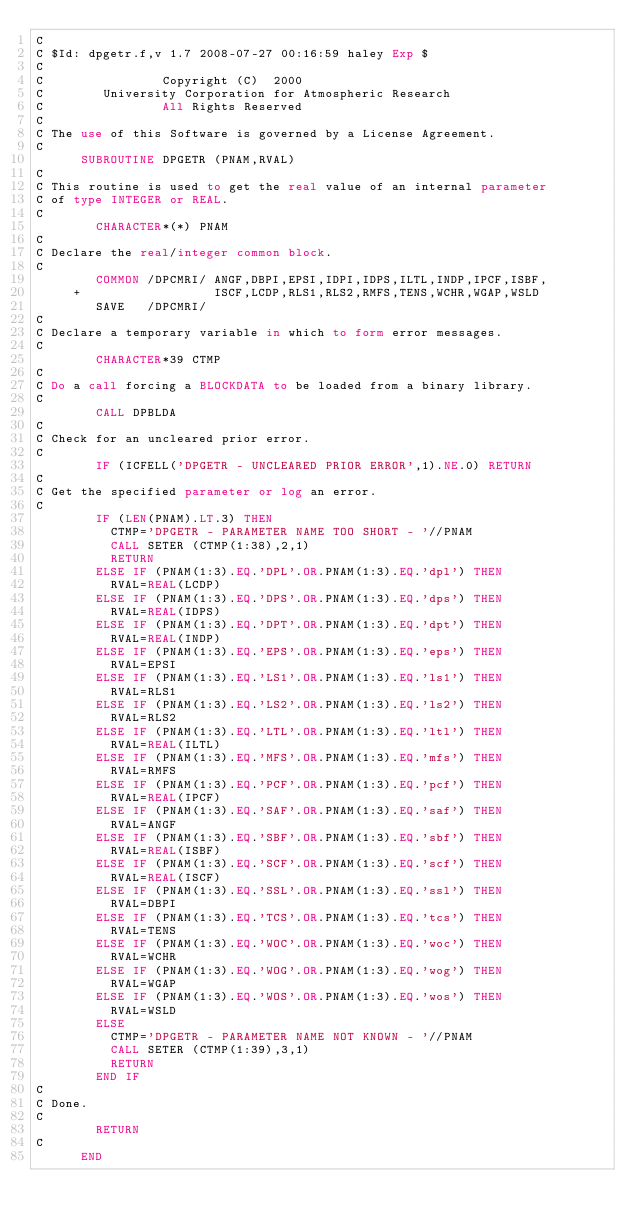<code> <loc_0><loc_0><loc_500><loc_500><_FORTRAN_>C
C $Id: dpgetr.f,v 1.7 2008-07-27 00:16:59 haley Exp $
C                                                                      
C                Copyright (C)  2000
C        University Corporation for Atmospheric Research
C                All Rights Reserved
C
C The use of this Software is governed by a License Agreement.
C
      SUBROUTINE DPGETR (PNAM,RVAL)
C
C This routine is used to get the real value of an internal parameter
C of type INTEGER or REAL.
C
        CHARACTER*(*) PNAM
C
C Declare the real/integer common block.
C
        COMMON /DPCMRI/ ANGF,DBPI,EPSI,IDPI,IDPS,ILTL,INDP,IPCF,ISBF,
     +                  ISCF,LCDP,RLS1,RLS2,RMFS,TENS,WCHR,WGAP,WSLD
        SAVE   /DPCMRI/
C
C Declare a temporary variable in which to form error messages.
C
        CHARACTER*39 CTMP
C
C Do a call forcing a BLOCKDATA to be loaded from a binary library.
C
        CALL DPBLDA
C
C Check for an uncleared prior error.
C
        IF (ICFELL('DPGETR - UNCLEARED PRIOR ERROR',1).NE.0) RETURN
C
C Get the specified parameter or log an error.
C
        IF (LEN(PNAM).LT.3) THEN
          CTMP='DPGETR - PARAMETER NAME TOO SHORT - '//PNAM
          CALL SETER (CTMP(1:38),2,1)
          RETURN
        ELSE IF (PNAM(1:3).EQ.'DPL'.OR.PNAM(1:3).EQ.'dpl') THEN
          RVAL=REAL(LCDP)
        ELSE IF (PNAM(1:3).EQ.'DPS'.OR.PNAM(1:3).EQ.'dps') THEN
          RVAL=REAL(IDPS)
        ELSE IF (PNAM(1:3).EQ.'DPT'.OR.PNAM(1:3).EQ.'dpt') THEN
          RVAL=REAL(INDP)
        ELSE IF (PNAM(1:3).EQ.'EPS'.OR.PNAM(1:3).EQ.'eps') THEN
          RVAL=EPSI
        ELSE IF (PNAM(1:3).EQ.'LS1'.OR.PNAM(1:3).EQ.'ls1') THEN
          RVAL=RLS1
        ELSE IF (PNAM(1:3).EQ.'LS2'.OR.PNAM(1:3).EQ.'ls2') THEN
          RVAL=RLS2
        ELSE IF (PNAM(1:3).EQ.'LTL'.OR.PNAM(1:3).EQ.'ltl') THEN
          RVAL=REAL(ILTL)
        ELSE IF (PNAM(1:3).EQ.'MFS'.OR.PNAM(1:3).EQ.'mfs') THEN
          RVAL=RMFS
        ELSE IF (PNAM(1:3).EQ.'PCF'.OR.PNAM(1:3).EQ.'pcf') THEN
          RVAL=REAL(IPCF)
        ELSE IF (PNAM(1:3).EQ.'SAF'.OR.PNAM(1:3).EQ.'saf') THEN
          RVAL=ANGF
        ELSE IF (PNAM(1:3).EQ.'SBF'.OR.PNAM(1:3).EQ.'sbf') THEN
          RVAL=REAL(ISBF)
        ELSE IF (PNAM(1:3).EQ.'SCF'.OR.PNAM(1:3).EQ.'scf') THEN
          RVAL=REAL(ISCF)
        ELSE IF (PNAM(1:3).EQ.'SSL'.OR.PNAM(1:3).EQ.'ssl') THEN
          RVAL=DBPI
        ELSE IF (PNAM(1:3).EQ.'TCS'.OR.PNAM(1:3).EQ.'tcs') THEN
          RVAL=TENS
        ELSE IF (PNAM(1:3).EQ.'WOC'.OR.PNAM(1:3).EQ.'woc') THEN
          RVAL=WCHR
        ELSE IF (PNAM(1:3).EQ.'WOG'.OR.PNAM(1:3).EQ.'wog') THEN
          RVAL=WGAP
        ELSE IF (PNAM(1:3).EQ.'WOS'.OR.PNAM(1:3).EQ.'wos') THEN
          RVAL=WSLD
        ELSE
          CTMP='DPGETR - PARAMETER NAME NOT KNOWN - '//PNAM
          CALL SETER (CTMP(1:39),3,1)
          RETURN
        END IF
C
C Done.
C
        RETURN
C
      END
</code> 